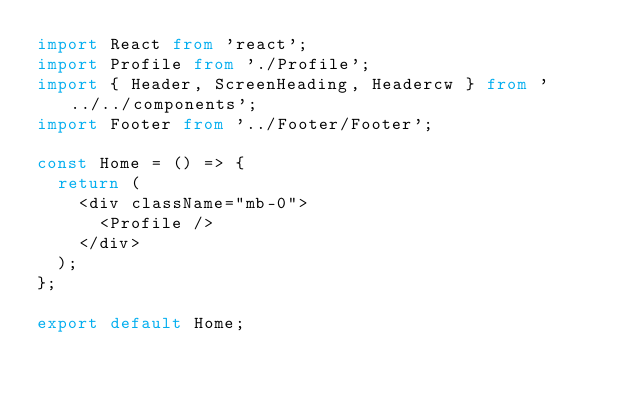<code> <loc_0><loc_0><loc_500><loc_500><_TypeScript_>import React from 'react';
import Profile from './Profile';
import { Header, ScreenHeading, Headercw } from '../../components';
import Footer from '../Footer/Footer';

const Home = () => {
  return (
    <div className="mb-0">
      <Profile />
    </div>
  );
};

export default Home;
</code> 